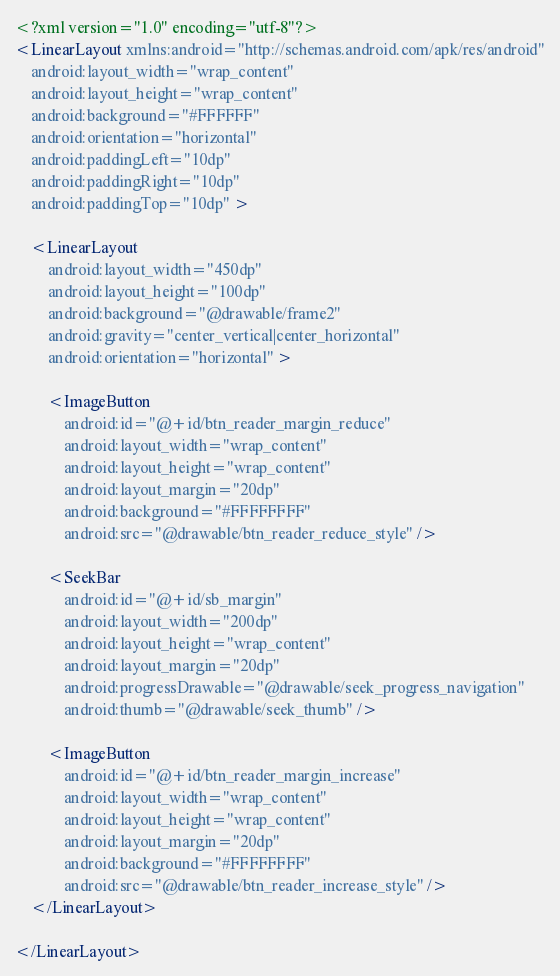Convert code to text. <code><loc_0><loc_0><loc_500><loc_500><_XML_><?xml version="1.0" encoding="utf-8"?>
<LinearLayout xmlns:android="http://schemas.android.com/apk/res/android"
    android:layout_width="wrap_content"
    android:layout_height="wrap_content"
    android:background="#FFFFFF"
    android:orientation="horizontal"
    android:paddingLeft="10dp"
    android:paddingRight="10dp"
    android:paddingTop="10dp" >

    <LinearLayout
        android:layout_width="450dp"
        android:layout_height="100dp"
        android:background="@drawable/frame2"
        android:gravity="center_vertical|center_horizontal"
        android:orientation="horizontal" >

        <ImageButton
            android:id="@+id/btn_reader_margin_reduce"
            android:layout_width="wrap_content"
            android:layout_height="wrap_content"
            android:layout_margin="20dp"
            android:background="#FFFFFFFF"
            android:src="@drawable/btn_reader_reduce_style" />

        <SeekBar
            android:id="@+id/sb_margin"
            android:layout_width="200dp"
            android:layout_height="wrap_content"
            android:layout_margin="20dp"
            android:progressDrawable="@drawable/seek_progress_navigation"
            android:thumb="@drawable/seek_thumb" />

        <ImageButton
            android:id="@+id/btn_reader_margin_increase"
            android:layout_width="wrap_content"
            android:layout_height="wrap_content"
            android:layout_margin="20dp"
            android:background="#FFFFFFFF"
            android:src="@drawable/btn_reader_increase_style" />
    </LinearLayout>

</LinearLayout></code> 